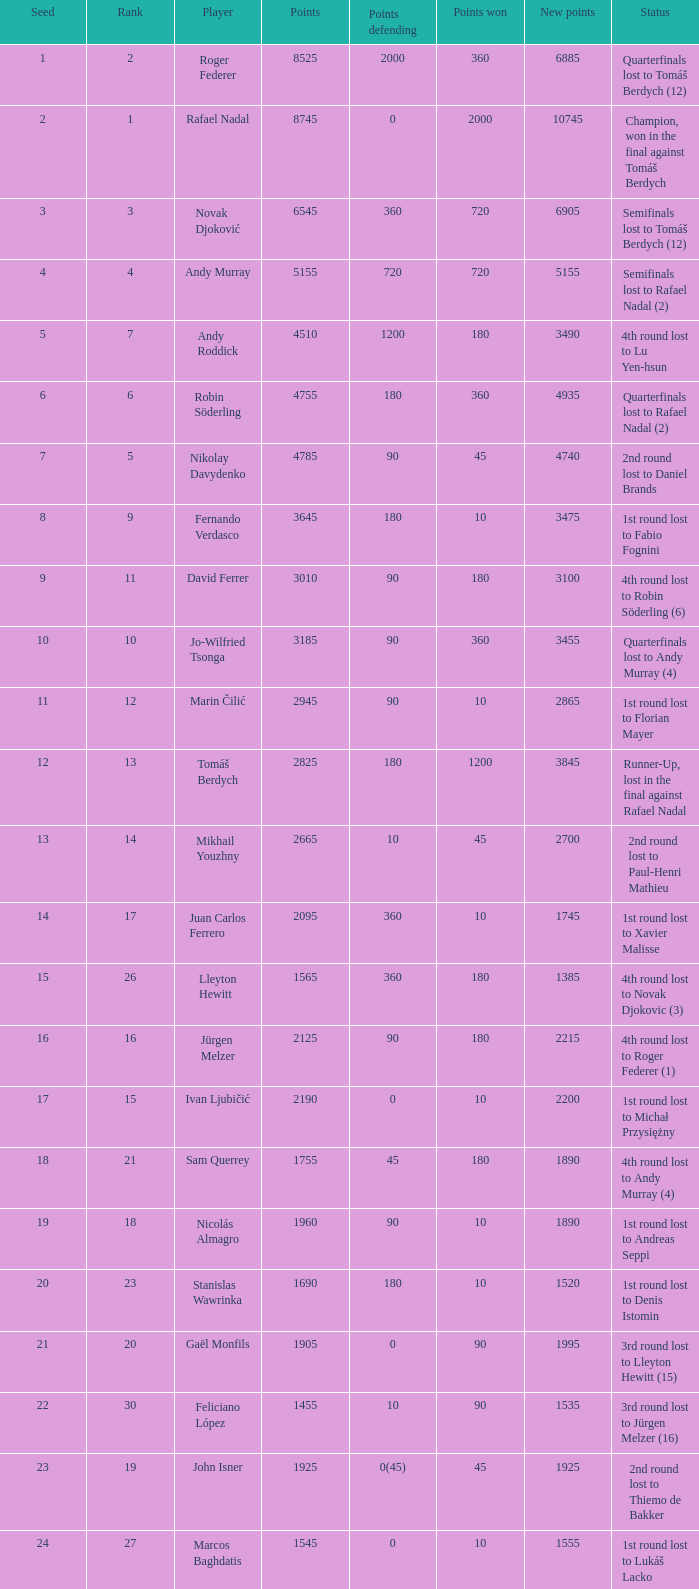Name the status for points 3185 Quarterfinals lost to Andy Murray (4). Can you give me this table as a dict? {'header': ['Seed', 'Rank', 'Player', 'Points', 'Points defending', 'Points won', 'New points', 'Status'], 'rows': [['1', '2', 'Roger Federer', '8525', '2000', '360', '6885', 'Quarterfinals lost to Tomáš Berdych (12)'], ['2', '1', 'Rafael Nadal', '8745', '0', '2000', '10745', 'Champion, won in the final against Tomáš Berdych'], ['3', '3', 'Novak Djoković', '6545', '360', '720', '6905', 'Semifinals lost to Tomáš Berdych (12)'], ['4', '4', 'Andy Murray', '5155', '720', '720', '5155', 'Semifinals lost to Rafael Nadal (2)'], ['5', '7', 'Andy Roddick', '4510', '1200', '180', '3490', '4th round lost to Lu Yen-hsun'], ['6', '6', 'Robin Söderling', '4755', '180', '360', '4935', 'Quarterfinals lost to Rafael Nadal (2)'], ['7', '5', 'Nikolay Davydenko', '4785', '90', '45', '4740', '2nd round lost to Daniel Brands'], ['8', '9', 'Fernando Verdasco', '3645', '180', '10', '3475', '1st round lost to Fabio Fognini'], ['9', '11', 'David Ferrer', '3010', '90', '180', '3100', '4th round lost to Robin Söderling (6)'], ['10', '10', 'Jo-Wilfried Tsonga', '3185', '90', '360', '3455', 'Quarterfinals lost to Andy Murray (4)'], ['11', '12', 'Marin Čilić', '2945', '90', '10', '2865', '1st round lost to Florian Mayer'], ['12', '13', 'Tomáš Berdych', '2825', '180', '1200', '3845', 'Runner-Up, lost in the final against Rafael Nadal'], ['13', '14', 'Mikhail Youzhny', '2665', '10', '45', '2700', '2nd round lost to Paul-Henri Mathieu'], ['14', '17', 'Juan Carlos Ferrero', '2095', '360', '10', '1745', '1st round lost to Xavier Malisse'], ['15', '26', 'Lleyton Hewitt', '1565', '360', '180', '1385', '4th round lost to Novak Djokovic (3)'], ['16', '16', 'Jürgen Melzer', '2125', '90', '180', '2215', '4th round lost to Roger Federer (1)'], ['17', '15', 'Ivan Ljubičić', '2190', '0', '10', '2200', '1st round lost to Michał Przysiężny'], ['18', '21', 'Sam Querrey', '1755', '45', '180', '1890', '4th round lost to Andy Murray (4)'], ['19', '18', 'Nicolás Almagro', '1960', '90', '10', '1890', '1st round lost to Andreas Seppi'], ['20', '23', 'Stanislas Wawrinka', '1690', '180', '10', '1520', '1st round lost to Denis Istomin'], ['21', '20', 'Gaël Monfils', '1905', '0', '90', '1995', '3rd round lost to Lleyton Hewitt (15)'], ['22', '30', 'Feliciano López', '1455', '10', '90', '1535', '3rd round lost to Jürgen Melzer (16)'], ['23', '19', 'John Isner', '1925', '0(45)', '45', '1925', '2nd round lost to Thiemo de Bakker'], ['24', '27', 'Marcos Baghdatis', '1545', '0', '10', '1555', '1st round lost to Lukáš Lacko'], ['25', '24', 'Thomaz Bellucci', '1652', '0(20)', '90', '1722', '3rd round lost to Robin Söderling (6)'], ['26', '32', 'Gilles Simon', '1305', '180', '90', '1215', '3rd round lost to Andy Murray (4)'], ['28', '31', 'Albert Montañés', '1405', '90', '90', '1405', '3rd round lost to Novak Djokovic (3)'], ['29', '35', 'Philipp Kohlschreiber', '1230', '90', '90', '1230', '3rd round lost to Andy Roddick (5)'], ['30', '36', 'Tommy Robredo', '1155', '90', '10', '1075', '1st round lost to Peter Luczak'], ['31', '37', 'Victor Hănescu', '1070', '45', '90', '1115', '3rd round lost to Daniel Brands'], ['32', '38', 'Julien Benneteau', '1059', '10', '180', '1229', '4th round lost to Jo-Wilfried Tsonga (10)']]} 